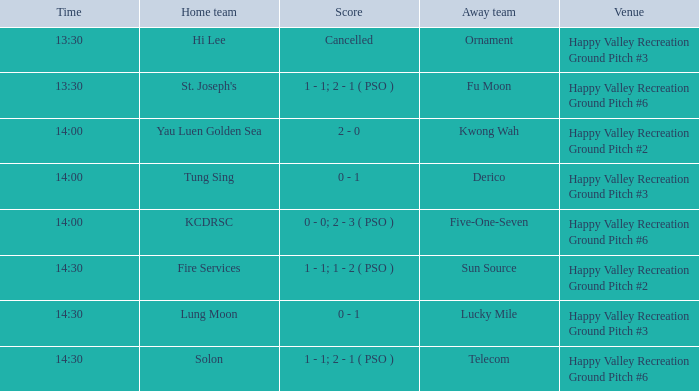Would you mind parsing the complete table? {'header': ['Time', 'Home team', 'Score', 'Away team', 'Venue'], 'rows': [['13:30', 'Hi Lee', 'Cancelled', 'Ornament', 'Happy Valley Recreation Ground Pitch #3'], ['13:30', "St. Joseph's", '1 - 1; 2 - 1 ( PSO )', 'Fu Moon', 'Happy Valley Recreation Ground Pitch #6'], ['14:00', 'Yau Luen Golden Sea', '2 - 0', 'Kwong Wah', 'Happy Valley Recreation Ground Pitch #2'], ['14:00', 'Tung Sing', '0 - 1', 'Derico', 'Happy Valley Recreation Ground Pitch #3'], ['14:00', 'KCDRSC', '0 - 0; 2 - 3 ( PSO )', 'Five-One-Seven', 'Happy Valley Recreation Ground Pitch #6'], ['14:30', 'Fire Services', '1 - 1; 1 - 2 ( PSO )', 'Sun Source', 'Happy Valley Recreation Ground Pitch #2'], ['14:30', 'Lung Moon', '0 - 1', 'Lucky Mile', 'Happy Valley Recreation Ground Pitch #3'], ['14:30', 'Solon', '1 - 1; 2 - 1 ( PSO )', 'Telecom', 'Happy Valley Recreation Ground Pitch #6']]} Where is the 14:30 match taking place, with sun source participating as the away team? Happy Valley Recreation Ground Pitch #2. 